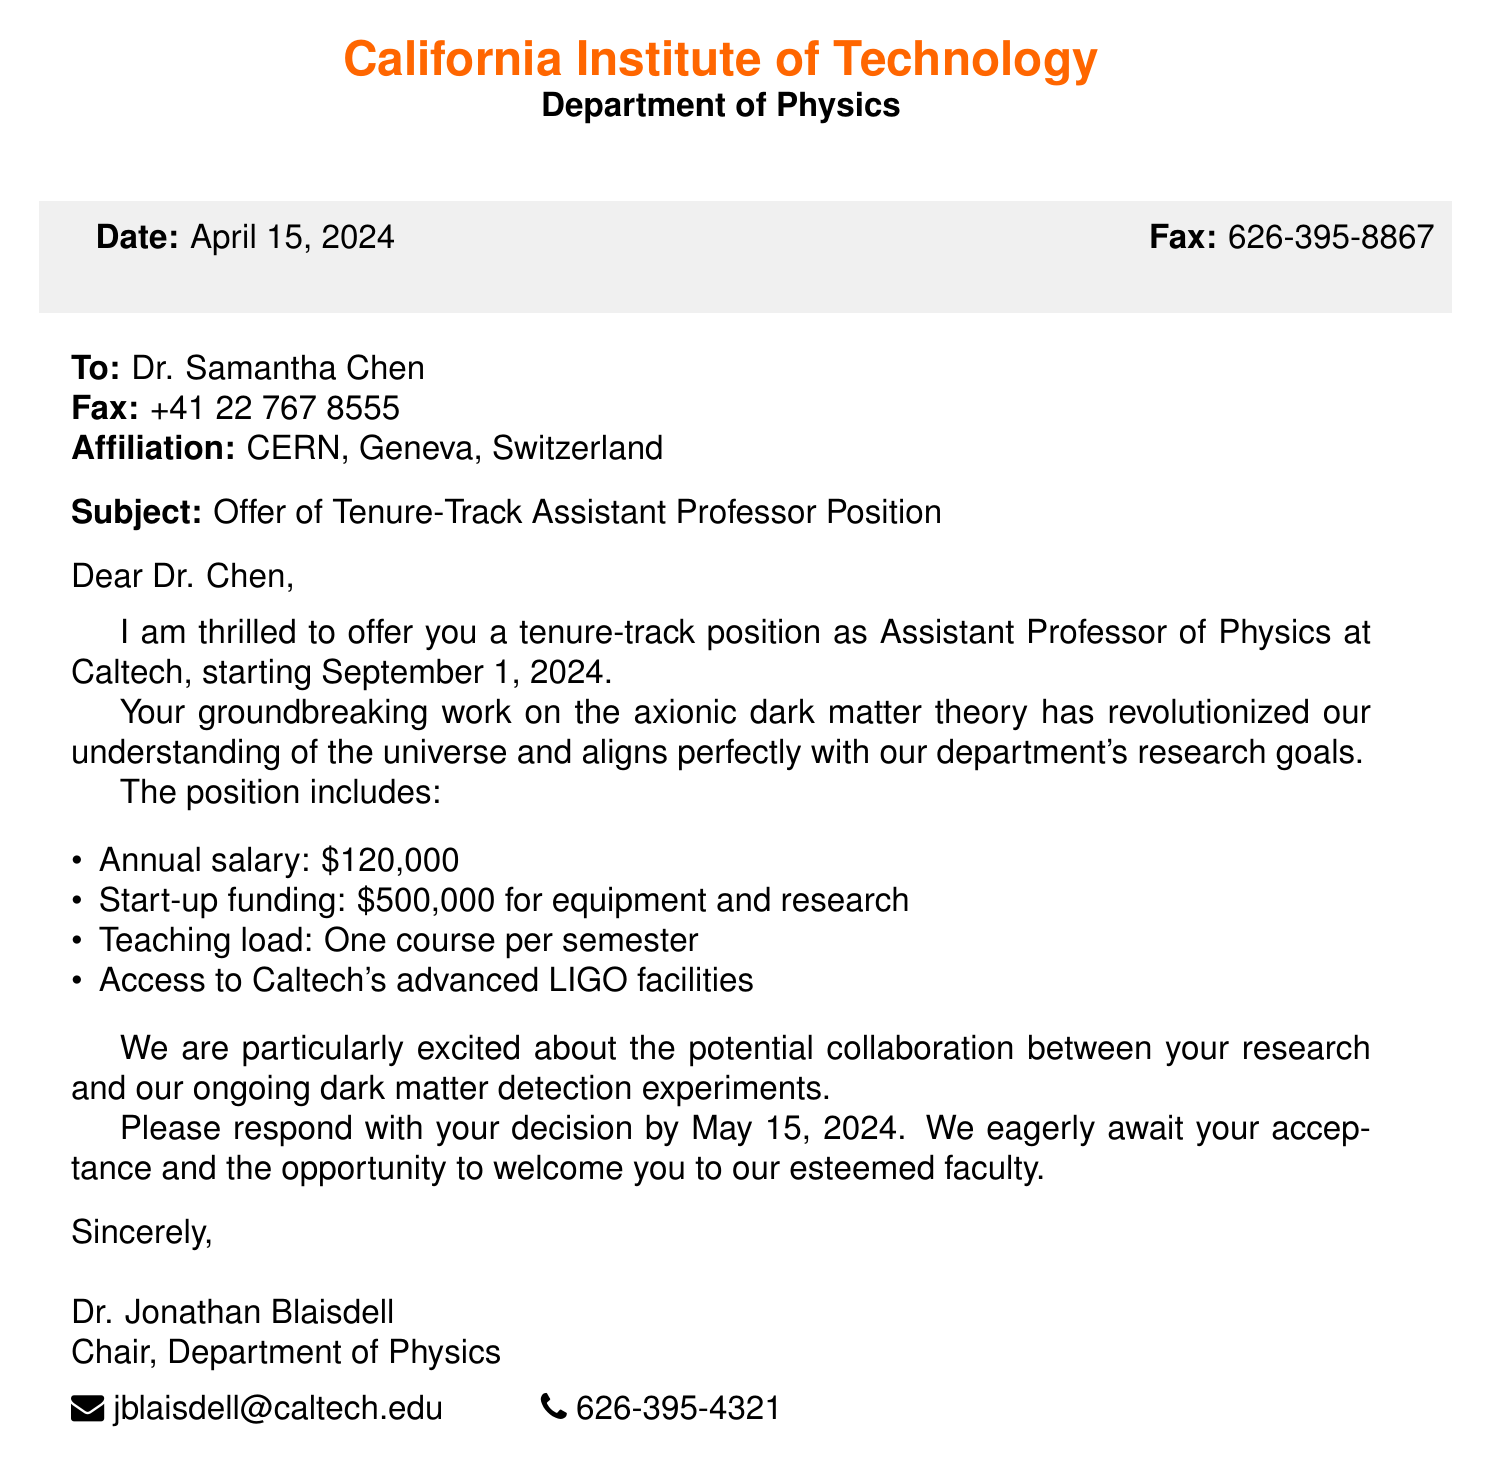What is the name of the recipient? The recipient's name is clearly stated at the beginning of the fax as Dr. Samantha Chen.
Answer: Dr. Samantha Chen What is the subject of the fax? The subject is mentioned in the subject line of the fax as the offer of a tenure-track position.
Answer: Offer of Tenure-Track Assistant Professor Position What is the annual salary offered? The fax specifies the annual salary, which is provided in the position details.
Answer: $120,000 When is the start date of the position? The start date of the position is indicated in the introductory paragraph of the document.
Answer: September 1, 2024 What is the amount of start-up funding? The start-up funding amount is listed in the details of the position offered.
Answer: $500,000 What is the teaching load for this position? The teaching load is specified as one course per semester in the document.
Answer: One course per semester What collaboration opportunity is mentioned? The document highlights a potential collaboration related to dark matter detection experiments.
Answer: Dark matter detection experiments What is the response deadline for the recipient? The deadline for the recipient's decision is stated clearly at the end of the offer.
Answer: May 15, 2024 Who is the chair of the Department of Physics? The name of the department chair is provided at the end of the fax.
Answer: Dr. Jonathan Blaisdell 